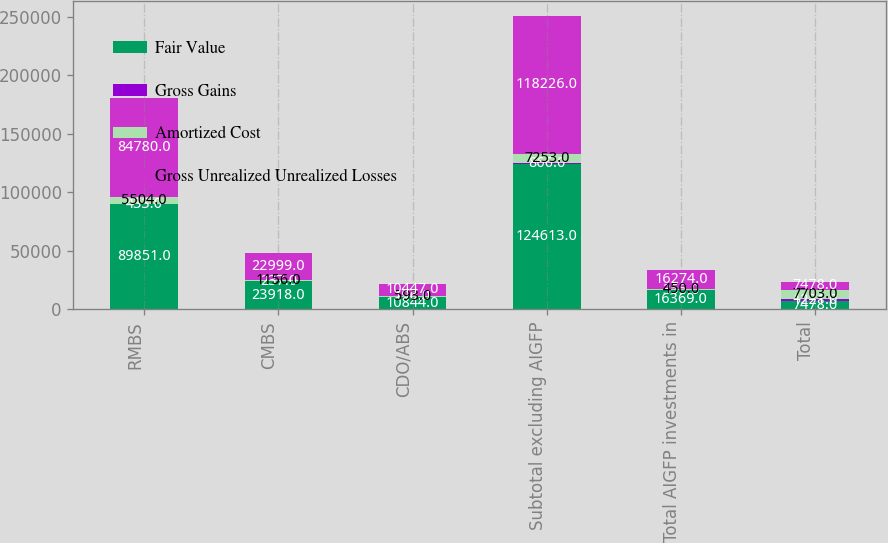Convert chart to OTSL. <chart><loc_0><loc_0><loc_500><loc_500><stacked_bar_chart><ecel><fcel>RMBS<fcel>CMBS<fcel>CDO/ABS<fcel>Subtotal excluding AIGFP<fcel>Total AIGFP investments in<fcel>Total<nl><fcel>Fair Value<fcel>89851<fcel>23918<fcel>10844<fcel>124613<fcel>16369<fcel>7478<nl><fcel>Gross Gains<fcel>433<fcel>237<fcel>196<fcel>866<fcel>355<fcel>1221<nl><fcel>Amortized Cost<fcel>5504<fcel>1156<fcel>593<fcel>7253<fcel>450<fcel>7703<nl><fcel>Gross Unrealized Unrealized Losses<fcel>84780<fcel>22999<fcel>10447<fcel>118226<fcel>16274<fcel>7478<nl></chart> 